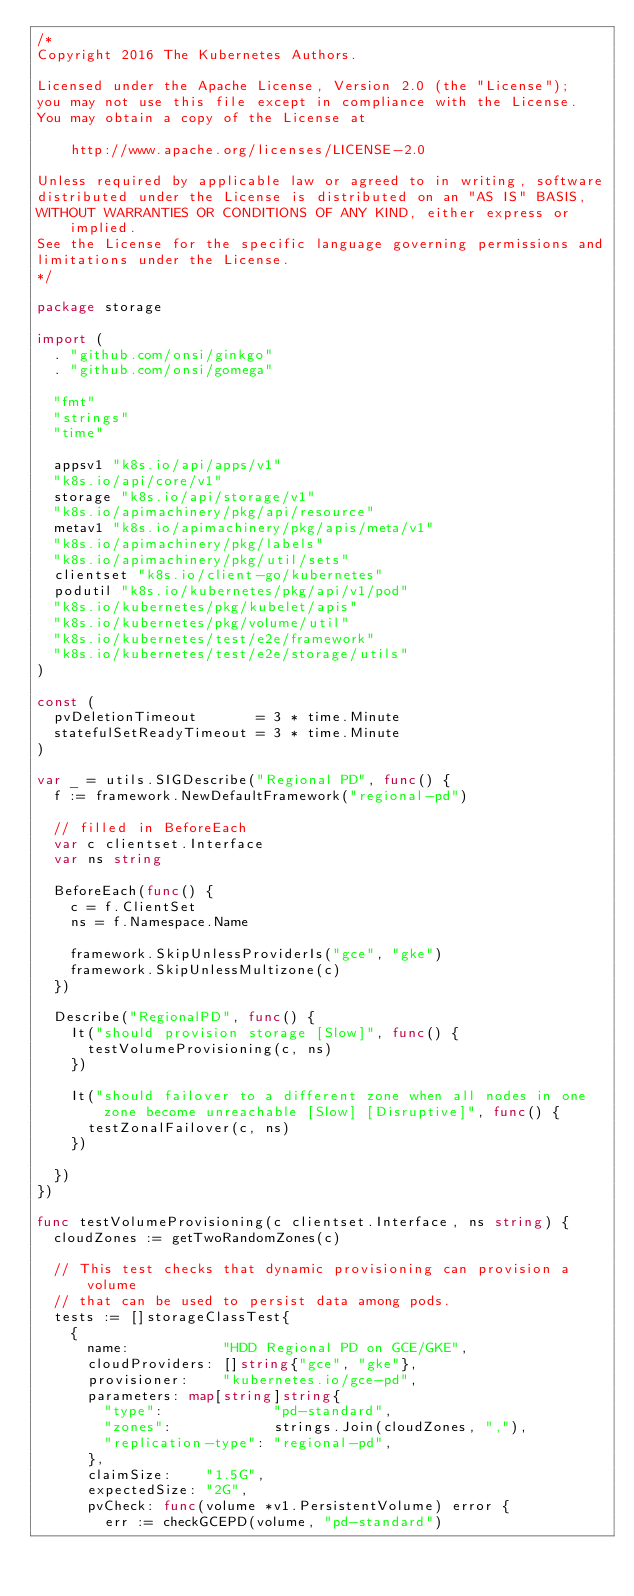Convert code to text. <code><loc_0><loc_0><loc_500><loc_500><_Go_>/*
Copyright 2016 The Kubernetes Authors.

Licensed under the Apache License, Version 2.0 (the "License");
you may not use this file except in compliance with the License.
You may obtain a copy of the License at

    http://www.apache.org/licenses/LICENSE-2.0

Unless required by applicable law or agreed to in writing, software
distributed under the License is distributed on an "AS IS" BASIS,
WITHOUT WARRANTIES OR CONDITIONS OF ANY KIND, either express or implied.
See the License for the specific language governing permissions and
limitations under the License.
*/

package storage

import (
	. "github.com/onsi/ginkgo"
	. "github.com/onsi/gomega"

	"fmt"
	"strings"
	"time"

	appsv1 "k8s.io/api/apps/v1"
	"k8s.io/api/core/v1"
	storage "k8s.io/api/storage/v1"
	"k8s.io/apimachinery/pkg/api/resource"
	metav1 "k8s.io/apimachinery/pkg/apis/meta/v1"
	"k8s.io/apimachinery/pkg/labels"
	"k8s.io/apimachinery/pkg/util/sets"
	clientset "k8s.io/client-go/kubernetes"
	podutil "k8s.io/kubernetes/pkg/api/v1/pod"
	"k8s.io/kubernetes/pkg/kubelet/apis"
	"k8s.io/kubernetes/pkg/volume/util"
	"k8s.io/kubernetes/test/e2e/framework"
	"k8s.io/kubernetes/test/e2e/storage/utils"
)

const (
	pvDeletionTimeout       = 3 * time.Minute
	statefulSetReadyTimeout = 3 * time.Minute
)

var _ = utils.SIGDescribe("Regional PD", func() {
	f := framework.NewDefaultFramework("regional-pd")

	// filled in BeforeEach
	var c clientset.Interface
	var ns string

	BeforeEach(func() {
		c = f.ClientSet
		ns = f.Namespace.Name

		framework.SkipUnlessProviderIs("gce", "gke")
		framework.SkipUnlessMultizone(c)
	})

	Describe("RegionalPD", func() {
		It("should provision storage [Slow]", func() {
			testVolumeProvisioning(c, ns)
		})

		It("should failover to a different zone when all nodes in one zone become unreachable [Slow] [Disruptive]", func() {
			testZonalFailover(c, ns)
		})

	})
})

func testVolumeProvisioning(c clientset.Interface, ns string) {
	cloudZones := getTwoRandomZones(c)

	// This test checks that dynamic provisioning can provision a volume
	// that can be used to persist data among pods.
	tests := []storageClassTest{
		{
			name:           "HDD Regional PD on GCE/GKE",
			cloudProviders: []string{"gce", "gke"},
			provisioner:    "kubernetes.io/gce-pd",
			parameters: map[string]string{
				"type":             "pd-standard",
				"zones":            strings.Join(cloudZones, ","),
				"replication-type": "regional-pd",
			},
			claimSize:    "1.5G",
			expectedSize: "2G",
			pvCheck: func(volume *v1.PersistentVolume) error {
				err := checkGCEPD(volume, "pd-standard")</code> 